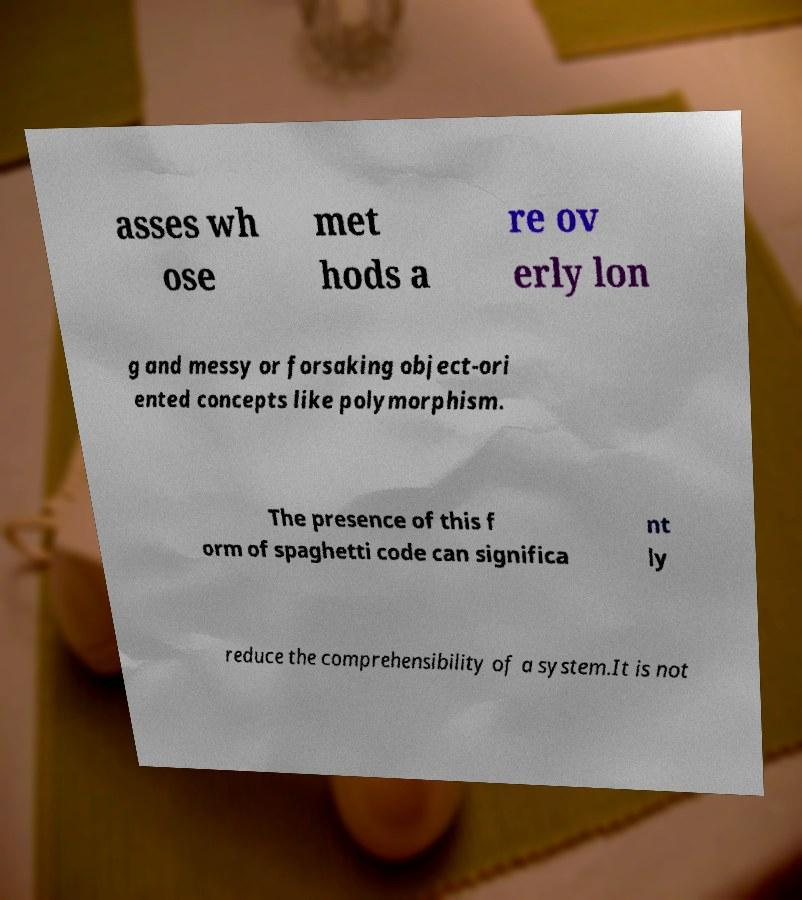Could you extract and type out the text from this image? asses wh ose met hods a re ov erly lon g and messy or forsaking object-ori ented concepts like polymorphism. The presence of this f orm of spaghetti code can significa nt ly reduce the comprehensibility of a system.It is not 